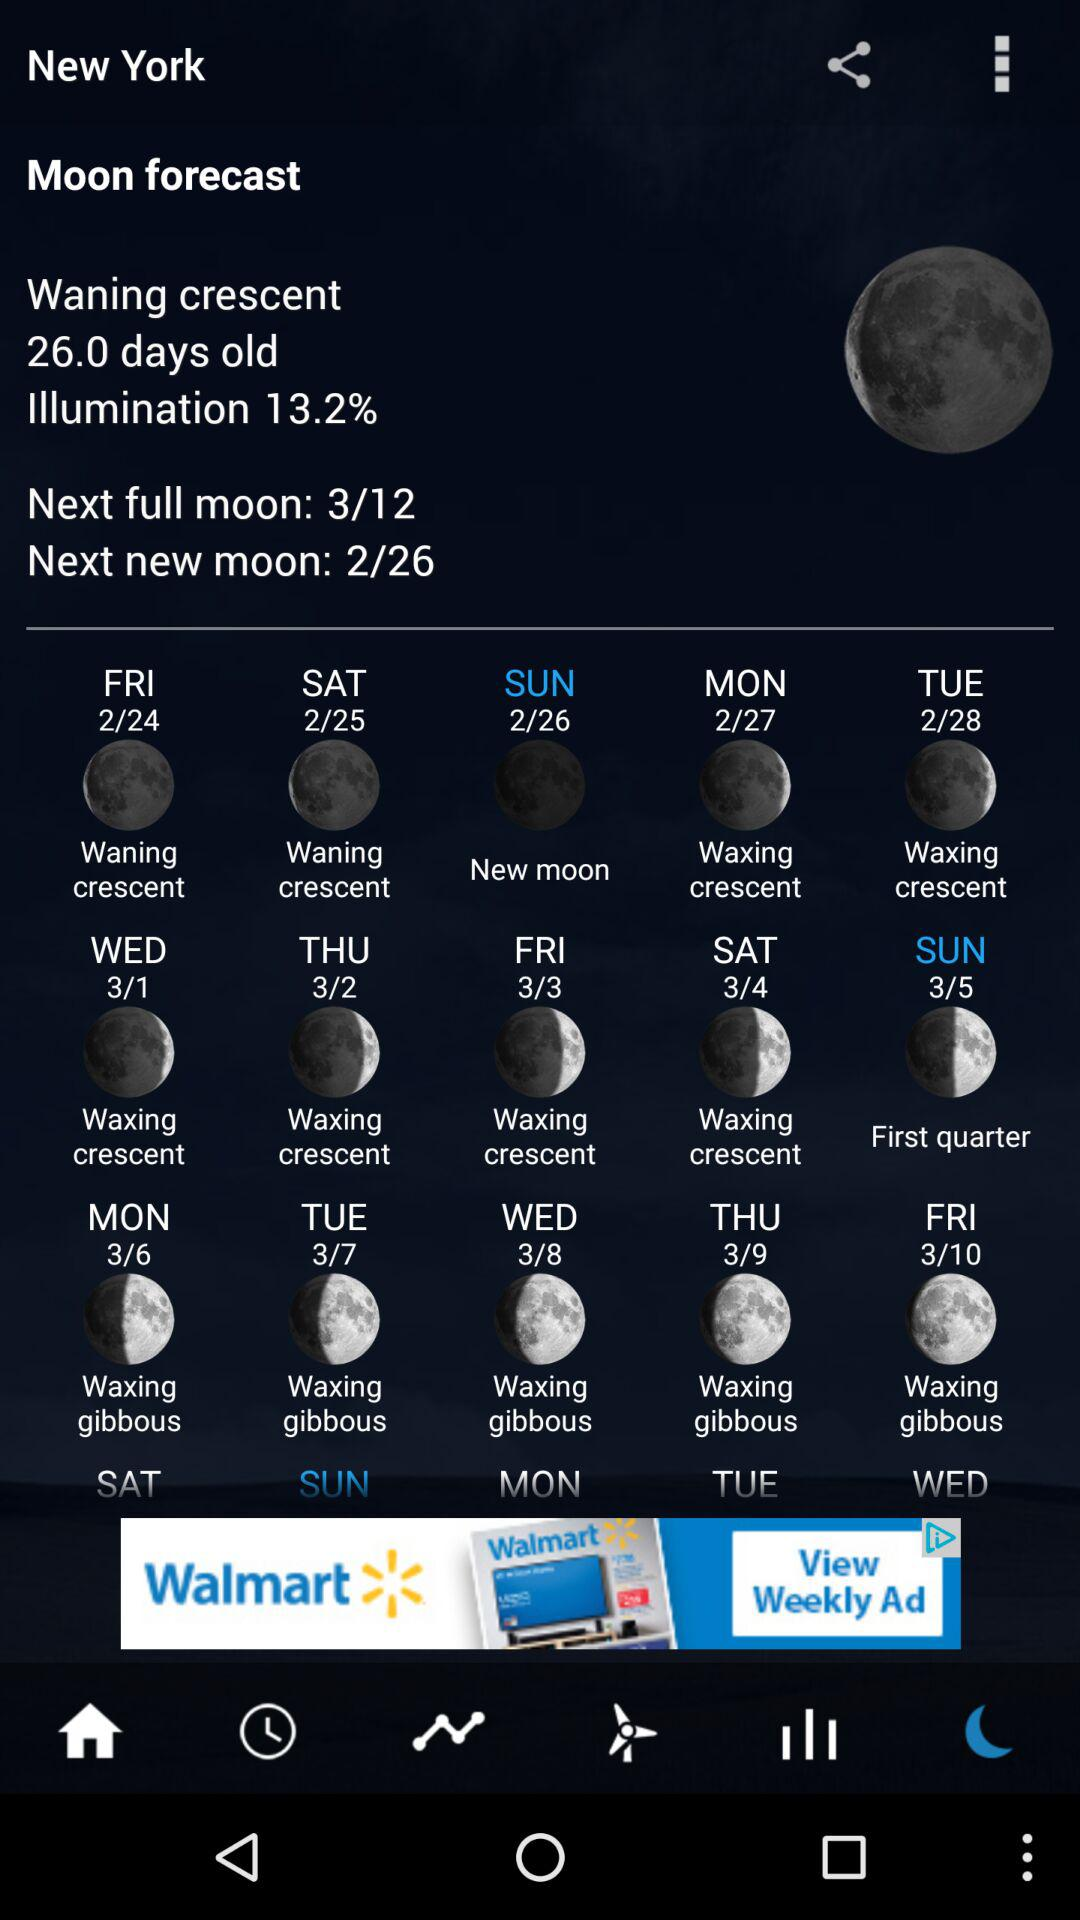When will be the next new moon? The next new moon will be on February 26. 